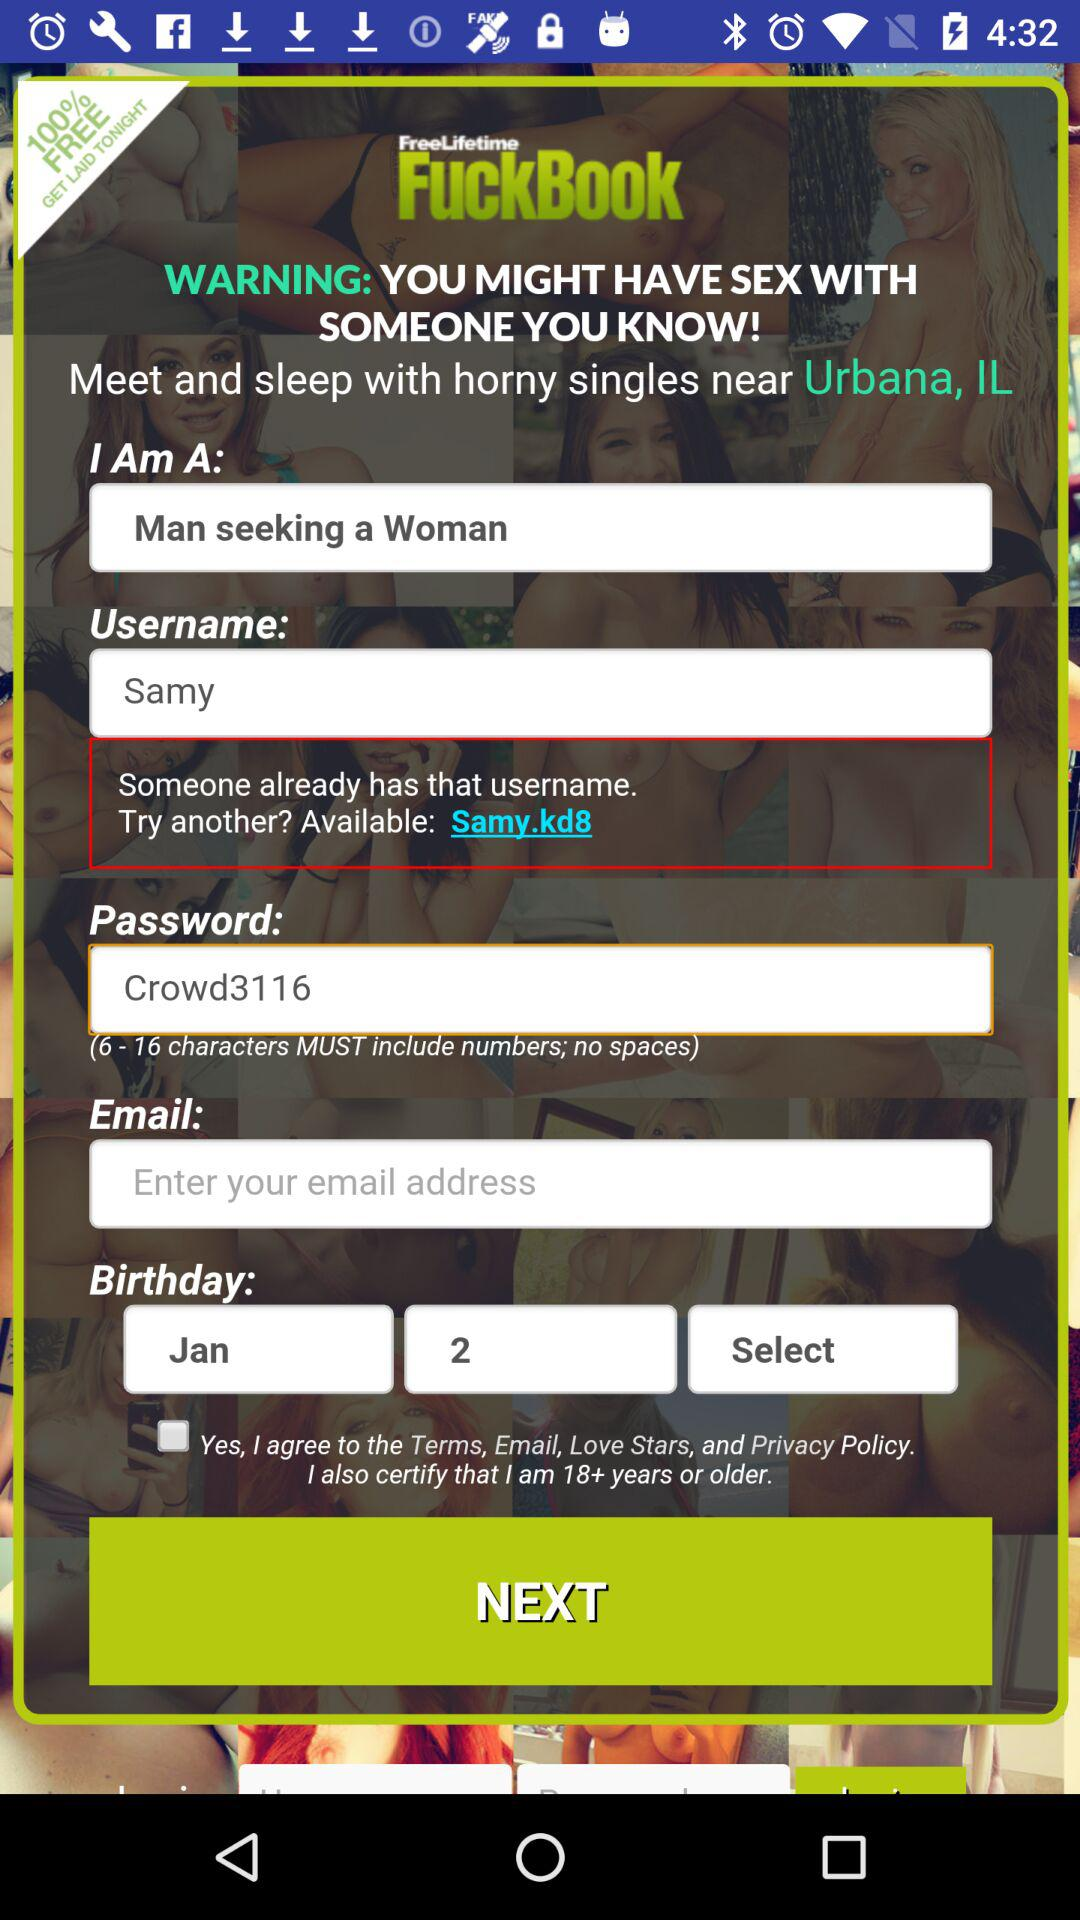What is the app name? The app name is "FuckBook". 